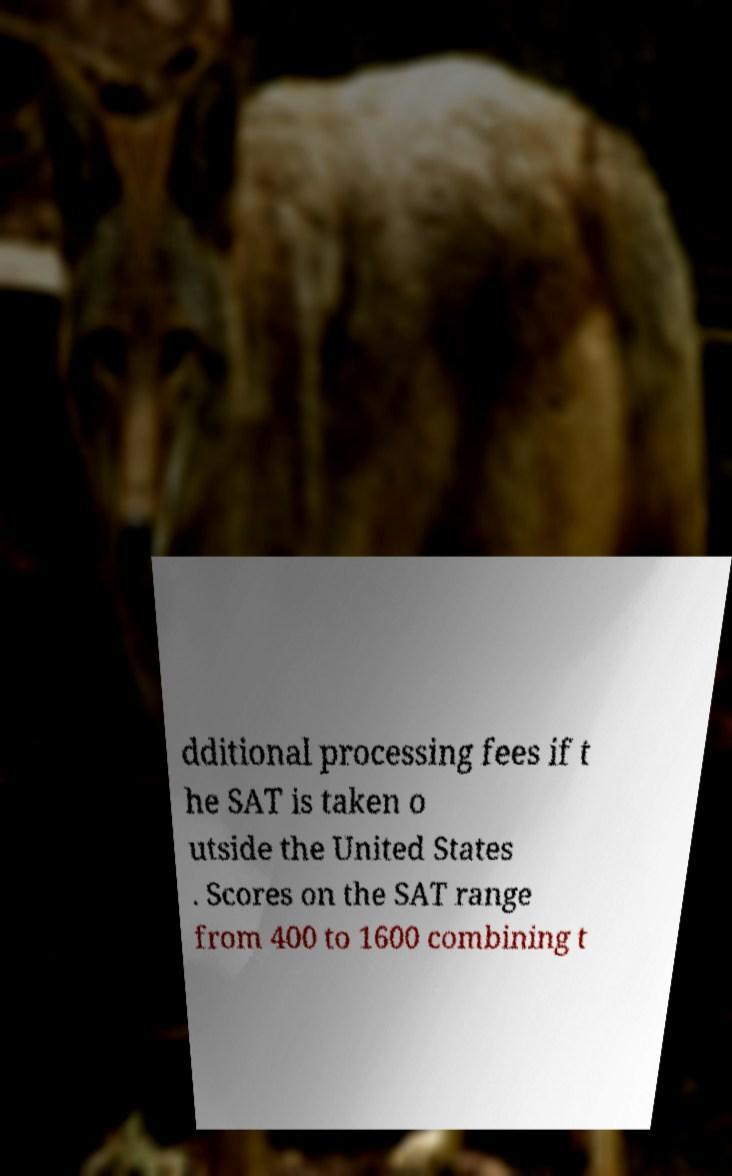I need the written content from this picture converted into text. Can you do that? dditional processing fees if t he SAT is taken o utside the United States . Scores on the SAT range from 400 to 1600 combining t 